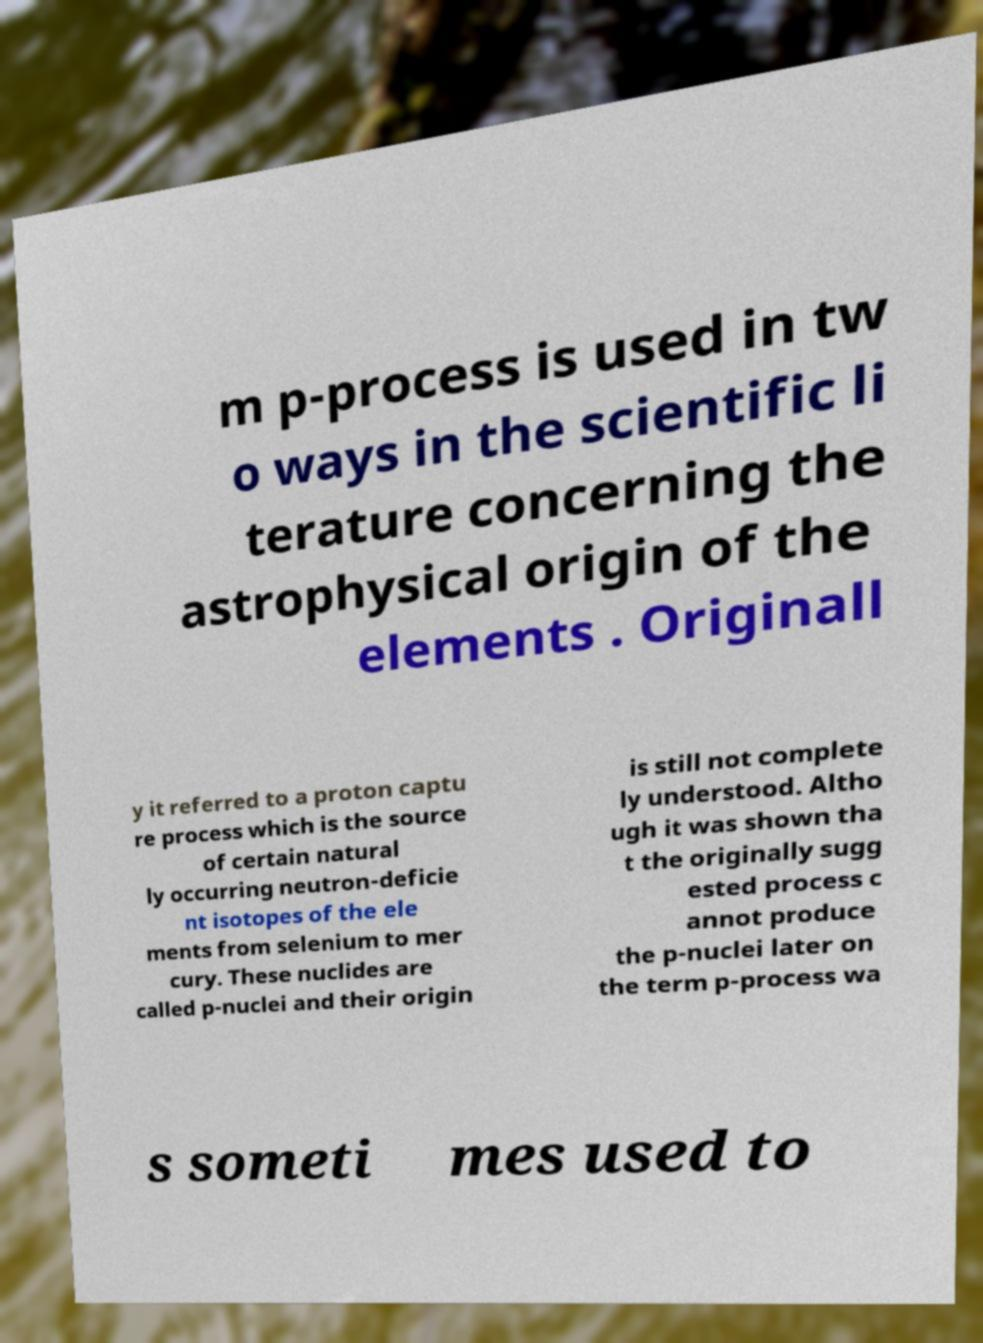Please identify and transcribe the text found in this image. m p-process is used in tw o ways in the scientific li terature concerning the astrophysical origin of the elements . Originall y it referred to a proton captu re process which is the source of certain natural ly occurring neutron-deficie nt isotopes of the ele ments from selenium to mer cury. These nuclides are called p-nuclei and their origin is still not complete ly understood. Altho ugh it was shown tha t the originally sugg ested process c annot produce the p-nuclei later on the term p-process wa s someti mes used to 